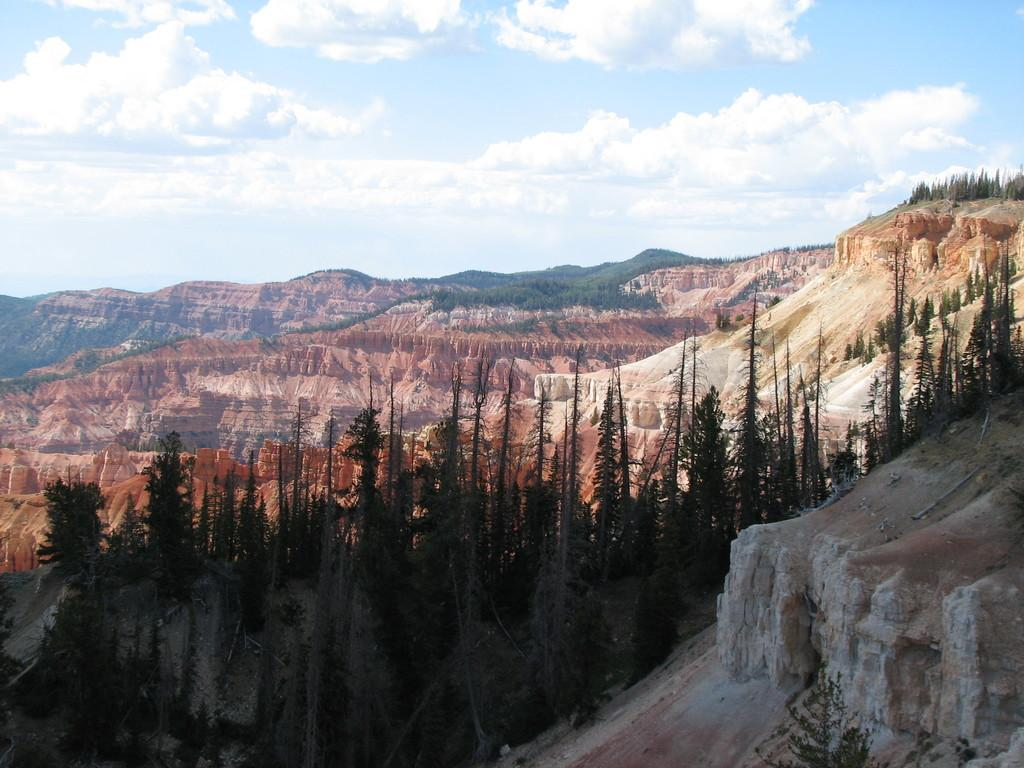What type of landscape feature can be seen in the image? There are hills in the image. What other natural elements are present in the image? There is a group of trees in the image. What part of the environment is visible in the image? The sky is visible in the image. How would you describe the sky in the image? The sky appears to be cloudy. Where is the toy located in the image? There is no toy present in the image. What is the significance of the middle in the image? The concept of "middle" is not applicable to the image, as it does not contain any elements that can be described as being in the middle. 